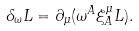<formula> <loc_0><loc_0><loc_500><loc_500>\delta _ { \omega } L = \partial _ { \mu } ( \omega ^ { A } \xi ^ { \mu } _ { A } L ) .</formula> 